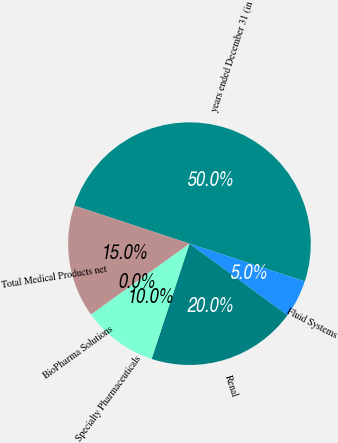<chart> <loc_0><loc_0><loc_500><loc_500><pie_chart><fcel>years ended December 31 (in<fcel>Fluid Systems<fcel>Renal<fcel>Specialty Pharmaceuticals<fcel>BioPharma Solutions<fcel>Total Medical Products net<nl><fcel>49.95%<fcel>5.02%<fcel>20.0%<fcel>10.01%<fcel>0.02%<fcel>15.0%<nl></chart> 